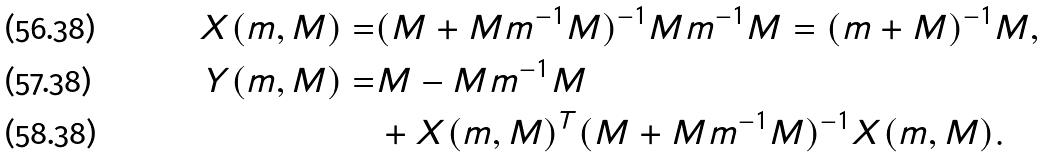<formula> <loc_0><loc_0><loc_500><loc_500>X ( m , M ) = & ( M + M m ^ { - 1 } M ) ^ { - 1 } M m ^ { - 1 } M = ( m + M ) ^ { - 1 } M , \\ Y ( m , M ) = & M - M m ^ { - 1 } M \\ & + X ( m , M ) ^ { T } ( M + M m ^ { - 1 } M ) ^ { - 1 } X ( m , M ) .</formula> 